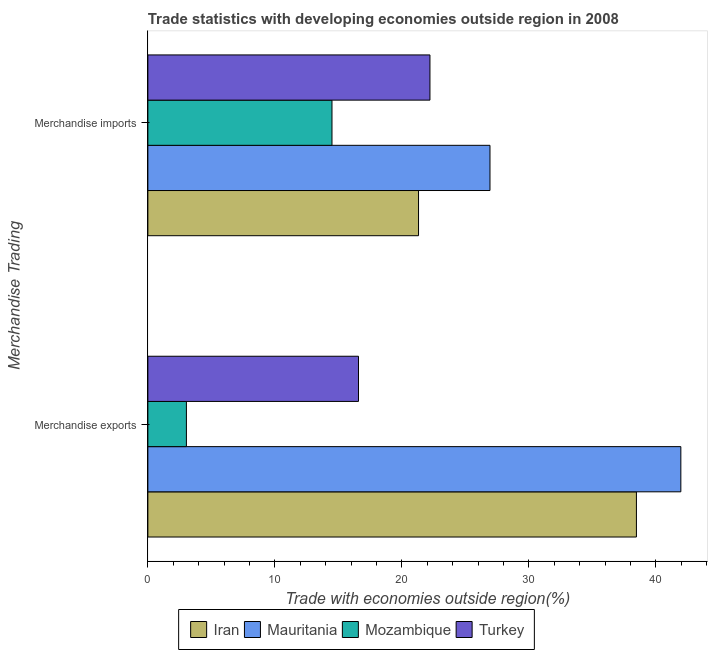How many different coloured bars are there?
Your response must be concise. 4. How many groups of bars are there?
Your answer should be very brief. 2. Are the number of bars per tick equal to the number of legend labels?
Your answer should be very brief. Yes. Are the number of bars on each tick of the Y-axis equal?
Make the answer very short. Yes. What is the merchandise imports in Mauritania?
Your response must be concise. 26.94. Across all countries, what is the maximum merchandise exports?
Give a very brief answer. 41.96. Across all countries, what is the minimum merchandise imports?
Your response must be concise. 14.5. In which country was the merchandise exports maximum?
Your answer should be very brief. Mauritania. In which country was the merchandise imports minimum?
Provide a short and direct response. Mozambique. What is the total merchandise imports in the graph?
Your answer should be compact. 84.95. What is the difference between the merchandise exports in Turkey and that in Iran?
Provide a succinct answer. -21.88. What is the difference between the merchandise exports in Mauritania and the merchandise imports in Turkey?
Provide a succinct answer. 19.75. What is the average merchandise exports per country?
Offer a terse response. 25.01. What is the difference between the merchandise exports and merchandise imports in Mauritania?
Make the answer very short. 15.03. What is the ratio of the merchandise imports in Turkey to that in Mozambique?
Offer a very short reply. 1.53. In how many countries, is the merchandise imports greater than the average merchandise imports taken over all countries?
Your response must be concise. 3. What does the 3rd bar from the bottom in Merchandise imports represents?
Offer a very short reply. Mozambique. How many bars are there?
Your answer should be very brief. 8. How many countries are there in the graph?
Make the answer very short. 4. What is the difference between two consecutive major ticks on the X-axis?
Keep it short and to the point. 10. Does the graph contain any zero values?
Offer a terse response. No. Does the graph contain grids?
Your answer should be compact. No. How are the legend labels stacked?
Your answer should be very brief. Horizontal. What is the title of the graph?
Provide a succinct answer. Trade statistics with developing economies outside region in 2008. Does "St. Lucia" appear as one of the legend labels in the graph?
Provide a succinct answer. No. What is the label or title of the X-axis?
Give a very brief answer. Trade with economies outside region(%). What is the label or title of the Y-axis?
Make the answer very short. Merchandise Trading. What is the Trade with economies outside region(%) in Iran in Merchandise exports?
Make the answer very short. 38.46. What is the Trade with economies outside region(%) of Mauritania in Merchandise exports?
Make the answer very short. 41.96. What is the Trade with economies outside region(%) of Mozambique in Merchandise exports?
Ensure brevity in your answer.  3.03. What is the Trade with economies outside region(%) of Turkey in Merchandise exports?
Offer a very short reply. 16.58. What is the Trade with economies outside region(%) in Iran in Merchandise imports?
Provide a succinct answer. 21.31. What is the Trade with economies outside region(%) in Mauritania in Merchandise imports?
Ensure brevity in your answer.  26.94. What is the Trade with economies outside region(%) in Mozambique in Merchandise imports?
Your answer should be very brief. 14.5. What is the Trade with economies outside region(%) of Turkey in Merchandise imports?
Offer a terse response. 22.21. Across all Merchandise Trading, what is the maximum Trade with economies outside region(%) in Iran?
Make the answer very short. 38.46. Across all Merchandise Trading, what is the maximum Trade with economies outside region(%) of Mauritania?
Provide a short and direct response. 41.96. Across all Merchandise Trading, what is the maximum Trade with economies outside region(%) of Mozambique?
Make the answer very short. 14.5. Across all Merchandise Trading, what is the maximum Trade with economies outside region(%) of Turkey?
Your answer should be very brief. 22.21. Across all Merchandise Trading, what is the minimum Trade with economies outside region(%) of Iran?
Ensure brevity in your answer.  21.31. Across all Merchandise Trading, what is the minimum Trade with economies outside region(%) in Mauritania?
Your response must be concise. 26.94. Across all Merchandise Trading, what is the minimum Trade with economies outside region(%) of Mozambique?
Make the answer very short. 3.03. Across all Merchandise Trading, what is the minimum Trade with economies outside region(%) of Turkey?
Offer a very short reply. 16.58. What is the total Trade with economies outside region(%) in Iran in the graph?
Offer a very short reply. 59.77. What is the total Trade with economies outside region(%) in Mauritania in the graph?
Provide a succinct answer. 68.9. What is the total Trade with economies outside region(%) of Mozambique in the graph?
Your answer should be very brief. 17.53. What is the total Trade with economies outside region(%) of Turkey in the graph?
Make the answer very short. 38.79. What is the difference between the Trade with economies outside region(%) of Iran in Merchandise exports and that in Merchandise imports?
Ensure brevity in your answer.  17.15. What is the difference between the Trade with economies outside region(%) of Mauritania in Merchandise exports and that in Merchandise imports?
Your answer should be very brief. 15.03. What is the difference between the Trade with economies outside region(%) in Mozambique in Merchandise exports and that in Merchandise imports?
Offer a very short reply. -11.46. What is the difference between the Trade with economies outside region(%) of Turkey in Merchandise exports and that in Merchandise imports?
Provide a short and direct response. -5.63. What is the difference between the Trade with economies outside region(%) in Iran in Merchandise exports and the Trade with economies outside region(%) in Mauritania in Merchandise imports?
Your answer should be compact. 11.53. What is the difference between the Trade with economies outside region(%) of Iran in Merchandise exports and the Trade with economies outside region(%) of Mozambique in Merchandise imports?
Give a very brief answer. 23.97. What is the difference between the Trade with economies outside region(%) in Iran in Merchandise exports and the Trade with economies outside region(%) in Turkey in Merchandise imports?
Give a very brief answer. 16.26. What is the difference between the Trade with economies outside region(%) of Mauritania in Merchandise exports and the Trade with economies outside region(%) of Mozambique in Merchandise imports?
Offer a very short reply. 27.47. What is the difference between the Trade with economies outside region(%) of Mauritania in Merchandise exports and the Trade with economies outside region(%) of Turkey in Merchandise imports?
Offer a very short reply. 19.75. What is the difference between the Trade with economies outside region(%) in Mozambique in Merchandise exports and the Trade with economies outside region(%) in Turkey in Merchandise imports?
Provide a short and direct response. -19.17. What is the average Trade with economies outside region(%) in Iran per Merchandise Trading?
Give a very brief answer. 29.89. What is the average Trade with economies outside region(%) in Mauritania per Merchandise Trading?
Your response must be concise. 34.45. What is the average Trade with economies outside region(%) of Mozambique per Merchandise Trading?
Offer a terse response. 8.76. What is the average Trade with economies outside region(%) of Turkey per Merchandise Trading?
Give a very brief answer. 19.4. What is the difference between the Trade with economies outside region(%) in Iran and Trade with economies outside region(%) in Mauritania in Merchandise exports?
Provide a short and direct response. -3.5. What is the difference between the Trade with economies outside region(%) of Iran and Trade with economies outside region(%) of Mozambique in Merchandise exports?
Your response must be concise. 35.43. What is the difference between the Trade with economies outside region(%) in Iran and Trade with economies outside region(%) in Turkey in Merchandise exports?
Offer a terse response. 21.88. What is the difference between the Trade with economies outside region(%) of Mauritania and Trade with economies outside region(%) of Mozambique in Merchandise exports?
Make the answer very short. 38.93. What is the difference between the Trade with economies outside region(%) of Mauritania and Trade with economies outside region(%) of Turkey in Merchandise exports?
Offer a terse response. 25.38. What is the difference between the Trade with economies outside region(%) in Mozambique and Trade with economies outside region(%) in Turkey in Merchandise exports?
Give a very brief answer. -13.55. What is the difference between the Trade with economies outside region(%) in Iran and Trade with economies outside region(%) in Mauritania in Merchandise imports?
Make the answer very short. -5.63. What is the difference between the Trade with economies outside region(%) in Iran and Trade with economies outside region(%) in Mozambique in Merchandise imports?
Offer a terse response. 6.81. What is the difference between the Trade with economies outside region(%) in Iran and Trade with economies outside region(%) in Turkey in Merchandise imports?
Give a very brief answer. -0.9. What is the difference between the Trade with economies outside region(%) in Mauritania and Trade with economies outside region(%) in Mozambique in Merchandise imports?
Offer a very short reply. 12.44. What is the difference between the Trade with economies outside region(%) in Mauritania and Trade with economies outside region(%) in Turkey in Merchandise imports?
Your answer should be compact. 4.73. What is the difference between the Trade with economies outside region(%) of Mozambique and Trade with economies outside region(%) of Turkey in Merchandise imports?
Your response must be concise. -7.71. What is the ratio of the Trade with economies outside region(%) of Iran in Merchandise exports to that in Merchandise imports?
Provide a succinct answer. 1.8. What is the ratio of the Trade with economies outside region(%) in Mauritania in Merchandise exports to that in Merchandise imports?
Provide a succinct answer. 1.56. What is the ratio of the Trade with economies outside region(%) in Mozambique in Merchandise exports to that in Merchandise imports?
Provide a short and direct response. 0.21. What is the ratio of the Trade with economies outside region(%) of Turkey in Merchandise exports to that in Merchandise imports?
Keep it short and to the point. 0.75. What is the difference between the highest and the second highest Trade with economies outside region(%) in Iran?
Offer a very short reply. 17.15. What is the difference between the highest and the second highest Trade with economies outside region(%) in Mauritania?
Give a very brief answer. 15.03. What is the difference between the highest and the second highest Trade with economies outside region(%) in Mozambique?
Offer a terse response. 11.46. What is the difference between the highest and the second highest Trade with economies outside region(%) in Turkey?
Your answer should be compact. 5.63. What is the difference between the highest and the lowest Trade with economies outside region(%) of Iran?
Provide a short and direct response. 17.15. What is the difference between the highest and the lowest Trade with economies outside region(%) of Mauritania?
Provide a short and direct response. 15.03. What is the difference between the highest and the lowest Trade with economies outside region(%) of Mozambique?
Make the answer very short. 11.46. What is the difference between the highest and the lowest Trade with economies outside region(%) in Turkey?
Provide a short and direct response. 5.63. 